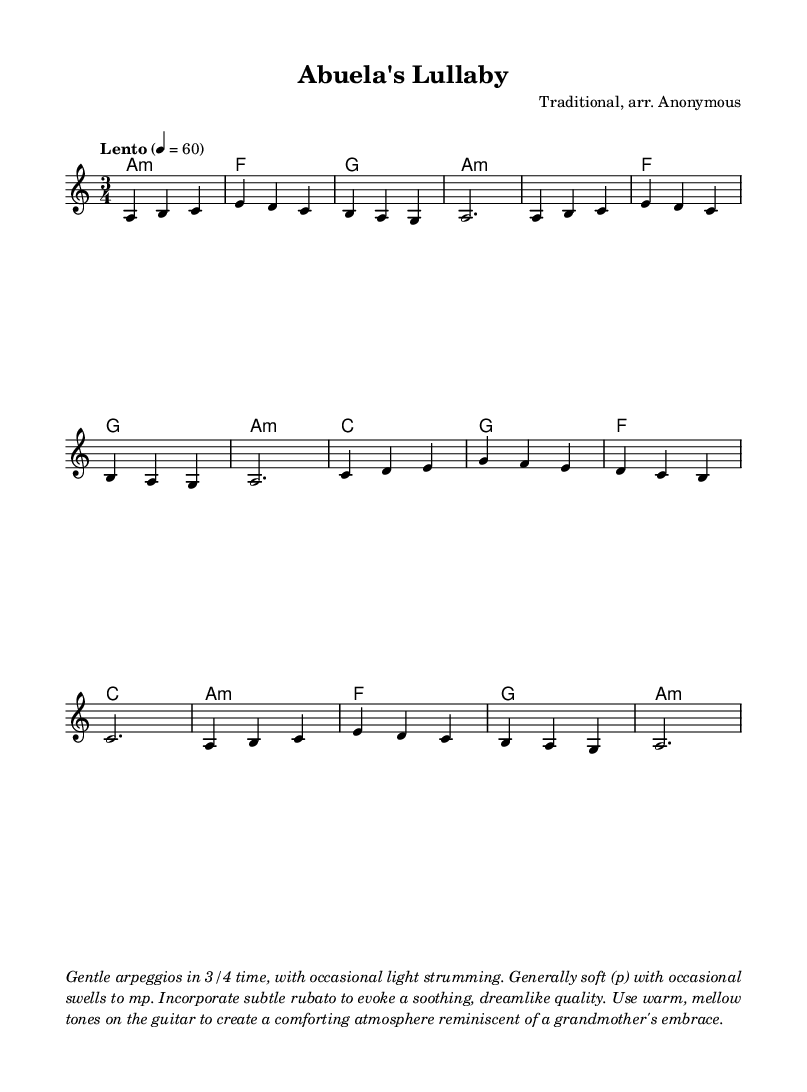What is the key signature of this music? The key signature is A minor, which has no sharps or flats. The absence of any sharps or flats in the key signature indicates it is A minor.
Answer: A minor What is the time signature of this piece? The time signature is 3/4, which denotes three beats per measure, with a quarter note receiving one beat. This can be determined by examining the numbers at the beginning of the music.
Answer: 3/4 What is the tempo marking for the piece? The tempo marking is "Lento," which indicates a slow tempo. This is noted in the tempo indication at the beginning of the score, associated with a metronome marking of 60 beats per minute.
Answer: Lento How many measures are in the melody? There are eight measures in the melody. This is counted by observing the grouping of musical notes separated by bar lines throughout the melody section.
Answer: Eight What dynamic level is primarily used in this piece? The dynamic level is generally soft (p). The description mentions soft dynamics with some variations to mezzo-piano (mp), indicating the predominant use of soft dynamics.
Answer: Soft (p) What type of guitar techniques are suggested in the performance notes? The performance notes suggest gentle arpeggios and light strumming. These techniques are mentioned explicitly in the instructions that accompany the music.
Answer: Gentle arpeggios What mood is intended to be conveyed through the music? The intended mood is soothing and comforting. The performance notes describe characteristics that evoke a dreamlike quality, reminiscent of a grandmother's embrace, contributing to a calming atmosphere.
Answer: Soothing and comforting 